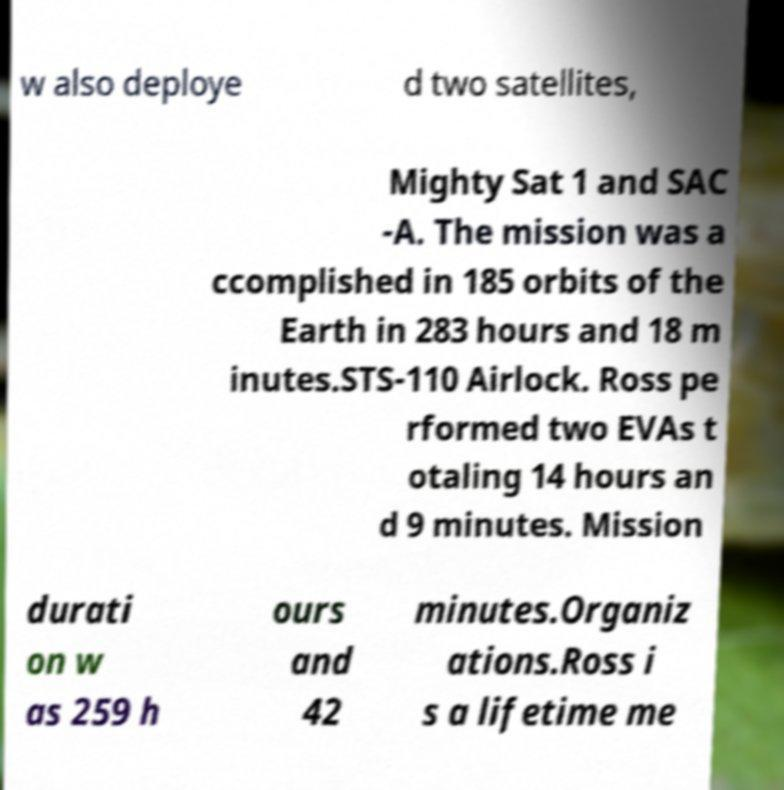Please identify and transcribe the text found in this image. w also deploye d two satellites, Mighty Sat 1 and SAC -A. The mission was a ccomplished in 185 orbits of the Earth in 283 hours and 18 m inutes.STS-110 Airlock. Ross pe rformed two EVAs t otaling 14 hours an d 9 minutes. Mission durati on w as 259 h ours and 42 minutes.Organiz ations.Ross i s a lifetime me 